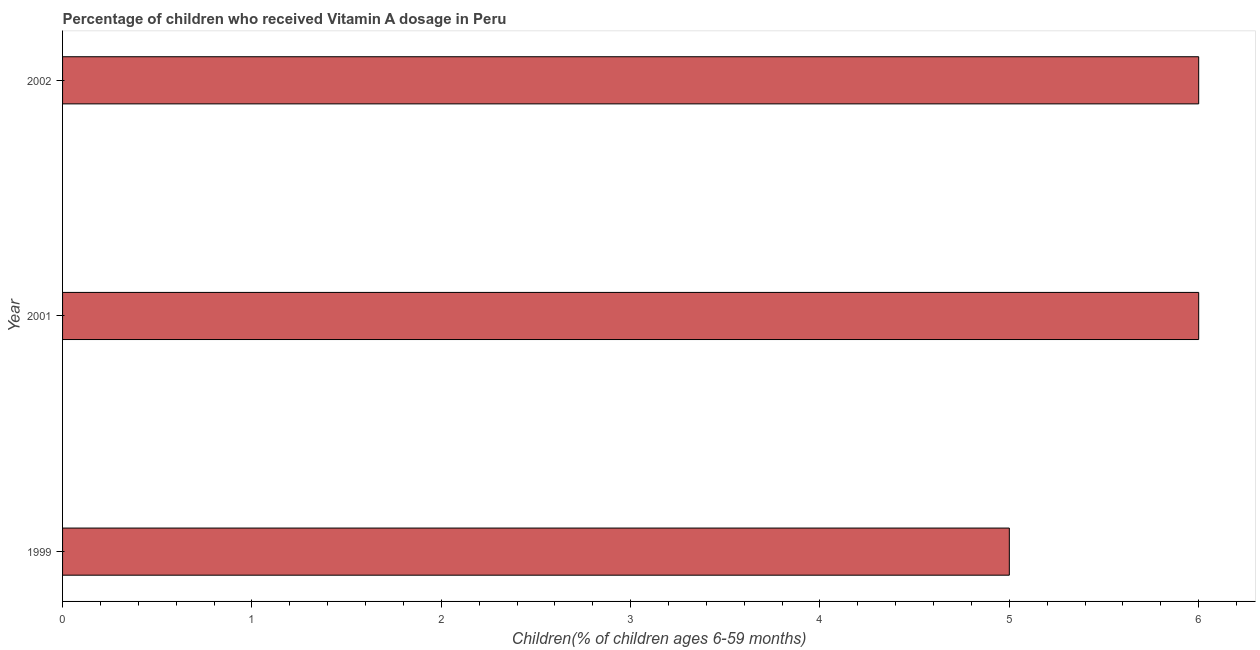What is the title of the graph?
Your answer should be compact. Percentage of children who received Vitamin A dosage in Peru. What is the label or title of the X-axis?
Give a very brief answer. Children(% of children ages 6-59 months). What is the vitamin a supplementation coverage rate in 2002?
Provide a succinct answer. 6. Across all years, what is the minimum vitamin a supplementation coverage rate?
Provide a succinct answer. 5. In which year was the vitamin a supplementation coverage rate minimum?
Your answer should be very brief. 1999. What is the sum of the vitamin a supplementation coverage rate?
Offer a very short reply. 17. What is the difference between the vitamin a supplementation coverage rate in 1999 and 2002?
Provide a succinct answer. -1. What is the median vitamin a supplementation coverage rate?
Give a very brief answer. 6. In how many years, is the vitamin a supplementation coverage rate greater than 4.4 %?
Ensure brevity in your answer.  3. Do a majority of the years between 1999 and 2002 (inclusive) have vitamin a supplementation coverage rate greater than 0.8 %?
Your answer should be very brief. Yes. What is the ratio of the vitamin a supplementation coverage rate in 1999 to that in 2001?
Give a very brief answer. 0.83. Is the vitamin a supplementation coverage rate in 1999 less than that in 2001?
Your answer should be compact. Yes. Is the difference between the vitamin a supplementation coverage rate in 1999 and 2002 greater than the difference between any two years?
Provide a short and direct response. Yes. Is the sum of the vitamin a supplementation coverage rate in 1999 and 2002 greater than the maximum vitamin a supplementation coverage rate across all years?
Offer a very short reply. Yes. What is the difference between the highest and the lowest vitamin a supplementation coverage rate?
Offer a very short reply. 1. Are all the bars in the graph horizontal?
Offer a very short reply. Yes. How many years are there in the graph?
Offer a very short reply. 3. Are the values on the major ticks of X-axis written in scientific E-notation?
Offer a very short reply. No. What is the Children(% of children ages 6-59 months) of 1999?
Provide a short and direct response. 5. What is the difference between the Children(% of children ages 6-59 months) in 1999 and 2002?
Give a very brief answer. -1. What is the ratio of the Children(% of children ages 6-59 months) in 1999 to that in 2001?
Offer a very short reply. 0.83. What is the ratio of the Children(% of children ages 6-59 months) in 1999 to that in 2002?
Ensure brevity in your answer.  0.83. What is the ratio of the Children(% of children ages 6-59 months) in 2001 to that in 2002?
Keep it short and to the point. 1. 